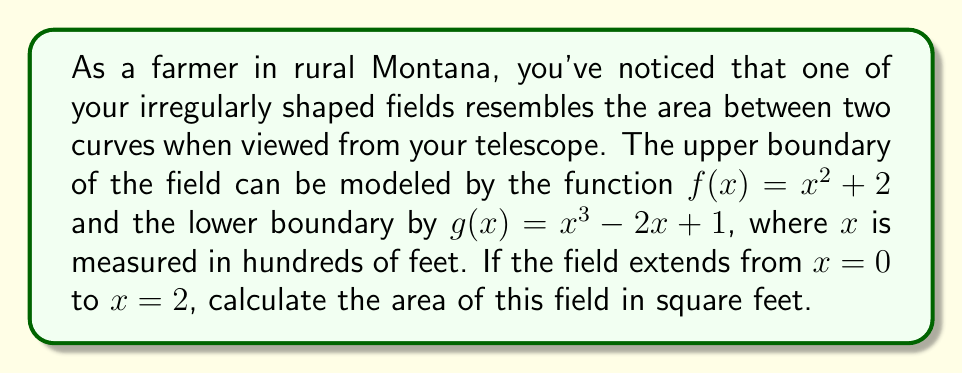Help me with this question. To calculate the area of the irregularly shaped field, we need to use polynomial integration. Here's how we can approach this problem step-by-step:

1) The area between two curves is given by the formula:

   $$A = \int_a^b [f(x) - g(x)] dx$$

   where $f(x)$ is the upper function and $g(x)$ is the lower function.

2) In this case, we have:
   $f(x) = x^2 + 2$
   $g(x) = x^3 - 2x + 1$
   $a = 0$ and $b = 2$

3) Let's set up the integral:

   $$A = \int_0^2 [(x^2 + 2) - (x^3 - 2x + 1)] dx$$

4) Simplify the integrand:

   $$A = \int_0^2 [-x^3 + x^2 + 2x + 1] dx$$

5) Integrate the polynomial:

   $$A = [-\frac{1}{4}x^4 + \frac{1}{3}x^3 + x^2 + x]_0^2$$

6) Evaluate the integral at the limits:

   $$A = [-\frac{1}{4}(2^4) + \frac{1}{3}(2^3) + 2^2 + 2] - [-\frac{1}{4}(0^4) + \frac{1}{3}(0^3) + 0^2 + 0]$$

7) Simplify:

   $$A = [-4 + \frac{8}{3} + 4 + 2] - [0] = \frac{14}{3}$$

8) Remember that $x$ was measured in hundreds of feet, so we need to convert our answer to square feet:

   $$A = \frac{14}{3} * 100^2 = \frac{140000}{3} \approx 46666.67 \text{ square feet}$$
Answer: $46666.67 \text{ ft}^2$ 